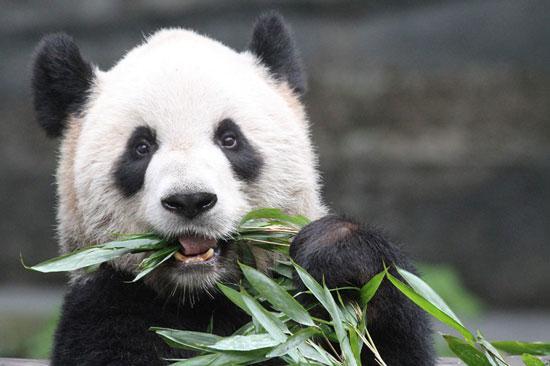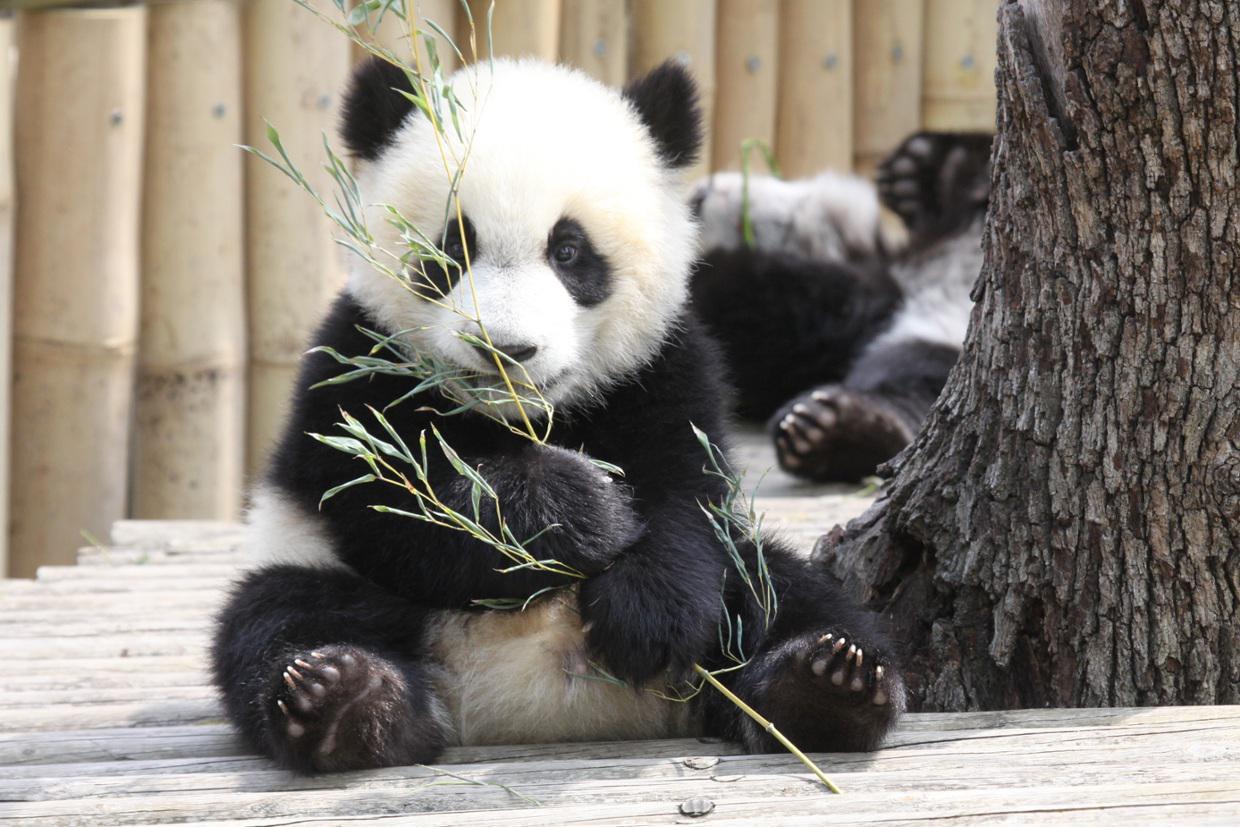The first image is the image on the left, the second image is the image on the right. Assess this claim about the two images: "Each image contains a single panda, and one image shows a panda reaching one paw toward a manmade object with a squarish base.". Correct or not? Answer yes or no. No. The first image is the image on the left, the second image is the image on the right. Considering the images on both sides, is "The panda on the left is shown with some green bamboo." valid? Answer yes or no. Yes. 